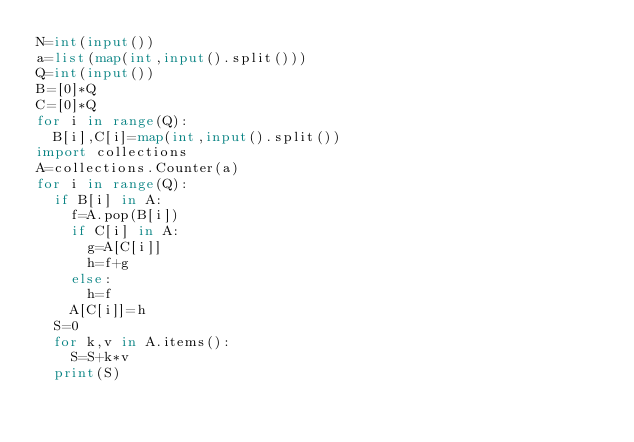<code> <loc_0><loc_0><loc_500><loc_500><_Python_>N=int(input())
a=list(map(int,input().split()))
Q=int(input())
B=[0]*Q
C=[0]*Q
for i in range(Q):
	B[i],C[i]=map(int,input().split())
import collections
A=collections.Counter(a)
for i in range(Q):
	if B[i] in A:
		f=A.pop(B[i])
		if C[i] in A:
			g=A[C[i]]
			h=f+g
		else:
			h=f
		A[C[i]]=h
	S=0
	for k,v in A.items():
		S=S+k*v
	print(S)</code> 